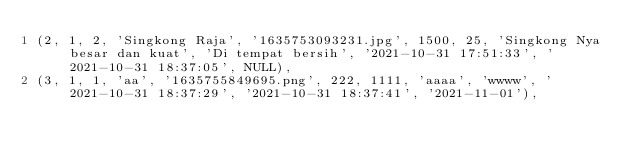Convert code to text. <code><loc_0><loc_0><loc_500><loc_500><_SQL_>(2, 1, 2, 'Singkong Raja', '1635753093231.jpg', 1500, 25, 'Singkong Nya besar dan kuat', 'Di tempat bersih', '2021-10-31 17:51:33', '2021-10-31 18:37:05', NULL),
(3, 1, 1, 'aa', '1635755849695.png', 222, 1111, 'aaaa', 'wwww', '2021-10-31 18:37:29', '2021-10-31 18:37:41', '2021-11-01'),</code> 